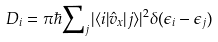<formula> <loc_0><loc_0><loc_500><loc_500>D _ { i } = \pi \hbar { \sum } _ { j } | \langle i | \hat { v } _ { x } | j \rangle | ^ { 2 } \delta ( \epsilon _ { i } - \epsilon _ { j } )</formula> 